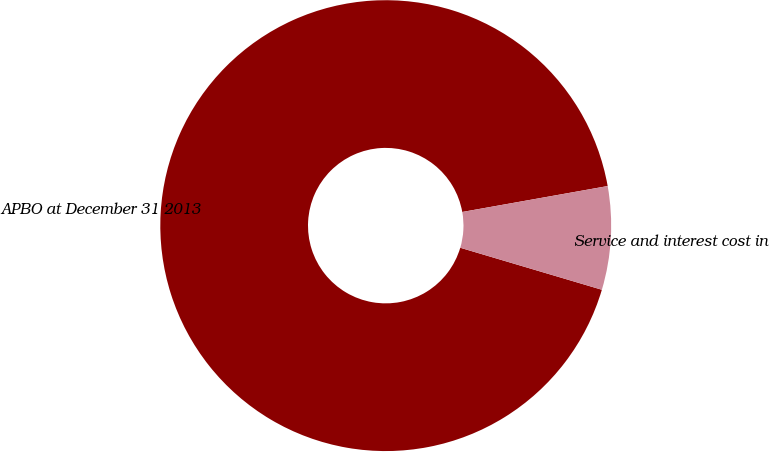Convert chart to OTSL. <chart><loc_0><loc_0><loc_500><loc_500><pie_chart><fcel>APBO at December 31 2013<fcel>Service and interest cost in<nl><fcel>92.6%<fcel>7.4%<nl></chart> 